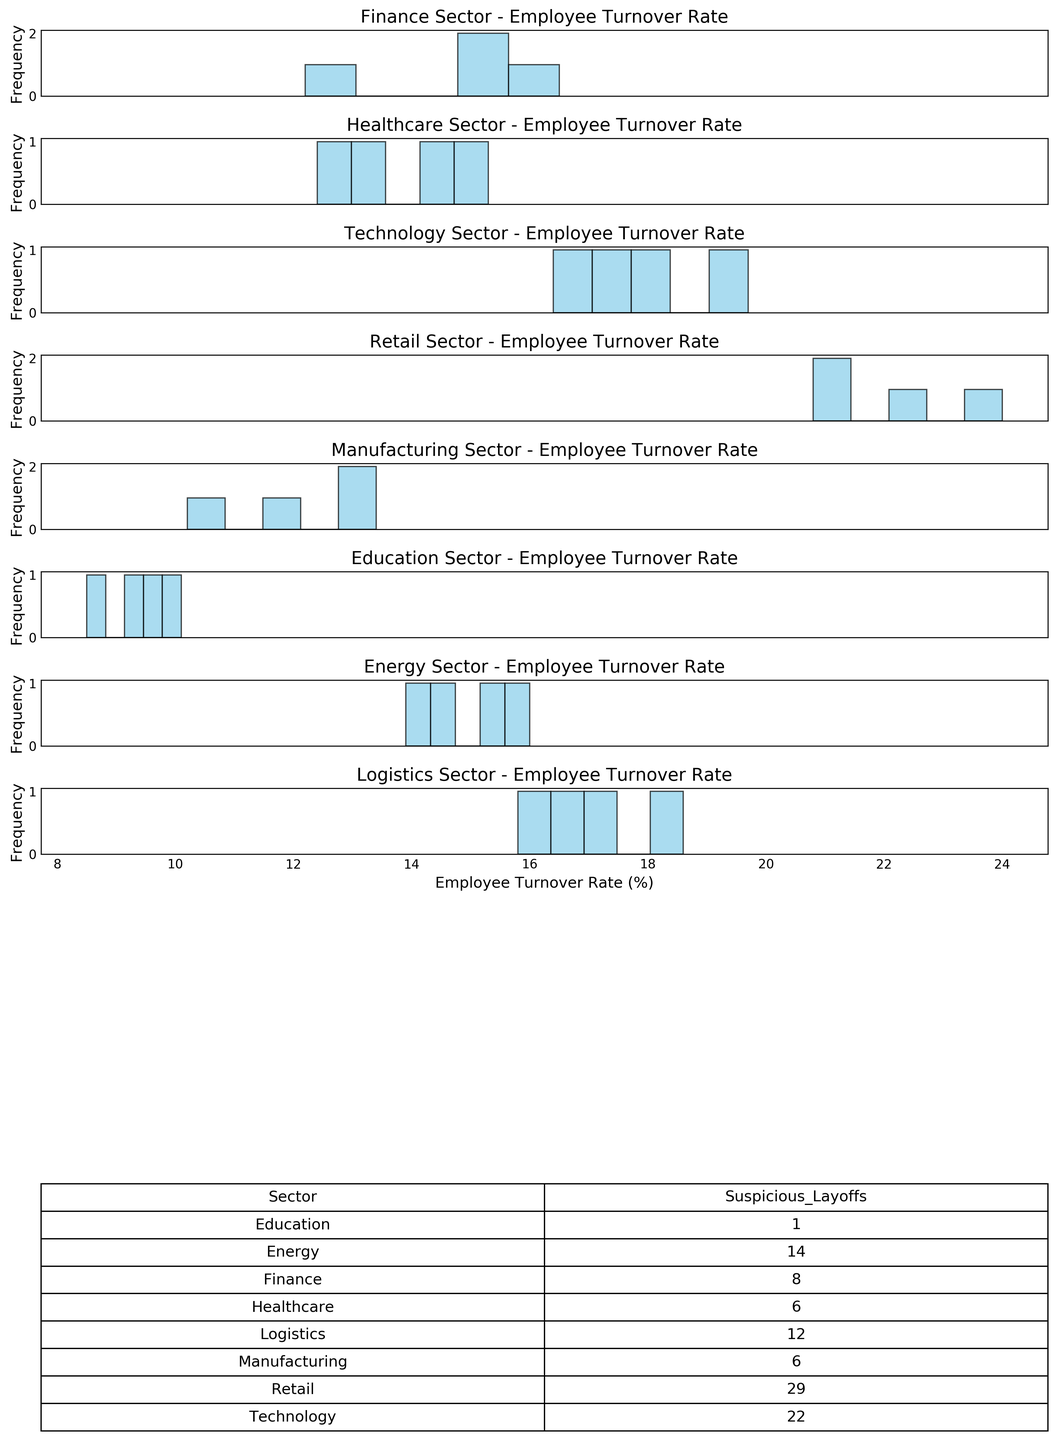what sector has the highest employee turnover rate histogram? To determine the sector with the highest employee turnover rate, look at the rightmost bar in the histograms. The Retail sector has the highest values in its histogram, with turnover rates reaching up to 24%.
Answer: Retail How many suspicious layoffs occurred in the Technology sector according to the summary table? Refer to the summary table showing the total number of suspicious layoffs by sector. The Technology sector recorded a total of 22 suspicious layoffs.
Answer: 22 Which histogram shows the most frequent employee turnover rate between 10% and 15%? Look at the frequency of employee turnover rates between 10% and 15%. The Manufacturing sector's histogram shows the most frequent turnover rates in this range.
Answer: Manufacturing What's the average suspicious layoffs in the Healthcare sector? The Healthcare sector shows the values of suspicious layoffs as [1, 0, 2, 3]. Summing up these values gives 1 + 0 + 2 + 3 = 6. There are 4 data points, so the average is 6/4 = 1.5.
Answer: 1.5 Compare the range of employee turnover rates in the Technology and Energy sectors. Which has a wider range? To determine the range, look at the lowest and highest turnover rates in the histograms. The Technology sector ranges from 16.4% to 19.7% (range is 3.3%), while the Energy sector ranges from 13.9% to 16.0% (range is 2.1%). Therefore, Technology has a wider range.
Answer: Technology What is the total number of suspicious layoffs in sectors other than Retail? Subtract the suspicious layoffs in Retail (29) from the total suspicious layoffs across all sectors as shown in the summary table. Total layoffs: 3+0+1+4+1+0+2+3+5+6+4+7+0+1+2+3+0+0+1+0+3+2+4+5+3+2+4+3 = 76; suspicous layoffs other than Retail: 76 - 29 = 47
Answer: 47 